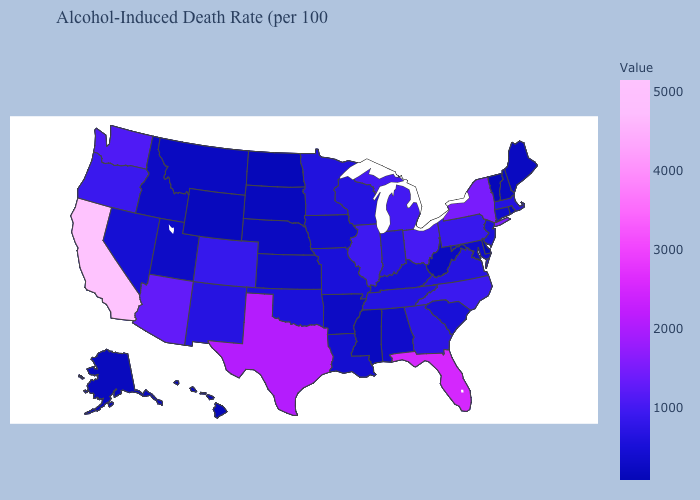Does Idaho have a lower value than Ohio?
Write a very short answer. Yes. Does the map have missing data?
Write a very short answer. No. Does Texas have the highest value in the USA?
Be succinct. No. Is the legend a continuous bar?
Give a very brief answer. Yes. Does California have the highest value in the USA?
Concise answer only. Yes. Does Montana have the highest value in the USA?
Write a very short answer. No. 